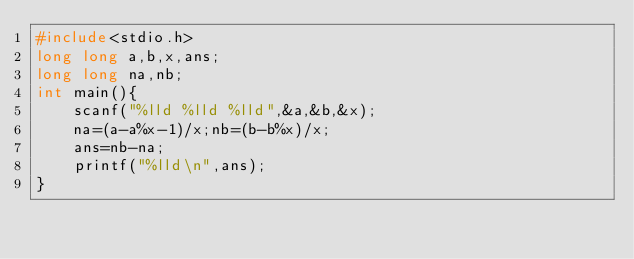Convert code to text. <code><loc_0><loc_0><loc_500><loc_500><_C_>#include<stdio.h>
long long a,b,x,ans;
long long na,nb;
int main(){
	scanf("%lld %lld %lld",&a,&b,&x);
	na=(a-a%x-1)/x;nb=(b-b%x)/x;
	ans=nb-na;
	printf("%lld\n",ans);
}
</code> 